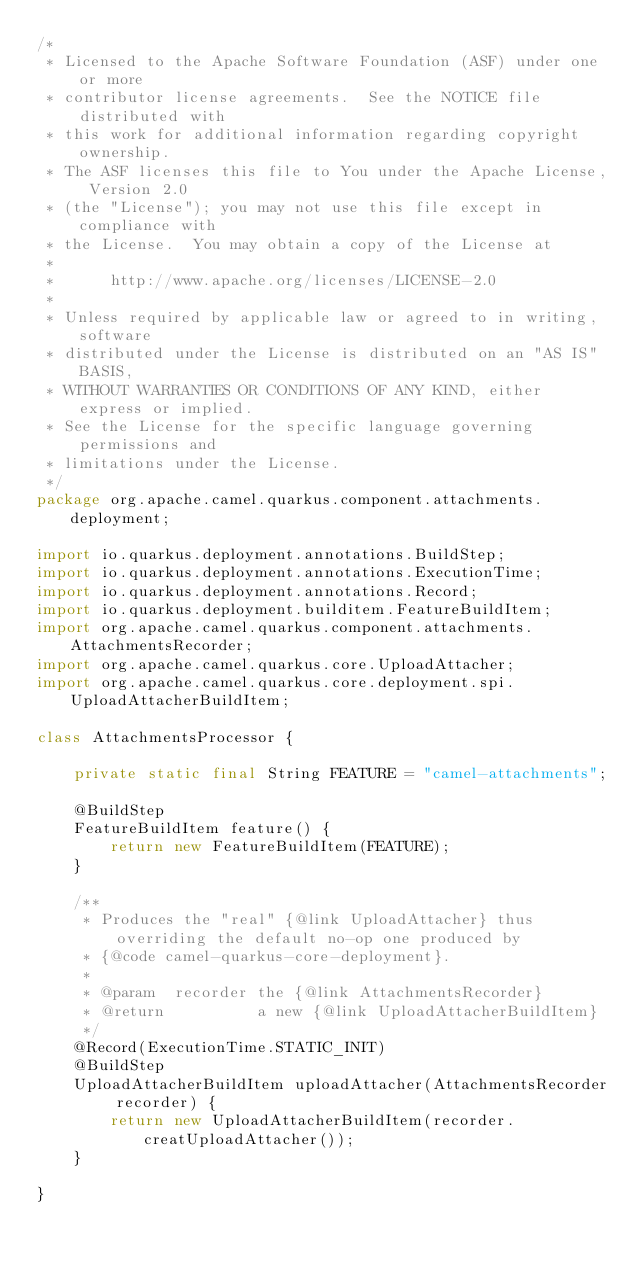Convert code to text. <code><loc_0><loc_0><loc_500><loc_500><_Java_>/*
 * Licensed to the Apache Software Foundation (ASF) under one or more
 * contributor license agreements.  See the NOTICE file distributed with
 * this work for additional information regarding copyright ownership.
 * The ASF licenses this file to You under the Apache License, Version 2.0
 * (the "License"); you may not use this file except in compliance with
 * the License.  You may obtain a copy of the License at
 *
 *      http://www.apache.org/licenses/LICENSE-2.0
 *
 * Unless required by applicable law or agreed to in writing, software
 * distributed under the License is distributed on an "AS IS" BASIS,
 * WITHOUT WARRANTIES OR CONDITIONS OF ANY KIND, either express or implied.
 * See the License for the specific language governing permissions and
 * limitations under the License.
 */
package org.apache.camel.quarkus.component.attachments.deployment;

import io.quarkus.deployment.annotations.BuildStep;
import io.quarkus.deployment.annotations.ExecutionTime;
import io.quarkus.deployment.annotations.Record;
import io.quarkus.deployment.builditem.FeatureBuildItem;
import org.apache.camel.quarkus.component.attachments.AttachmentsRecorder;
import org.apache.camel.quarkus.core.UploadAttacher;
import org.apache.camel.quarkus.core.deployment.spi.UploadAttacherBuildItem;

class AttachmentsProcessor {

    private static final String FEATURE = "camel-attachments";

    @BuildStep
    FeatureBuildItem feature() {
        return new FeatureBuildItem(FEATURE);
    }

    /**
     * Produces the "real" {@link UploadAttacher} thus overriding the default no-op one produced by
     * {@code camel-quarkus-core-deployment}.
     *
     * @param  recorder the {@link AttachmentsRecorder}
     * @return          a new {@link UploadAttacherBuildItem}
     */
    @Record(ExecutionTime.STATIC_INIT)
    @BuildStep
    UploadAttacherBuildItem uploadAttacher(AttachmentsRecorder recorder) {
        return new UploadAttacherBuildItem(recorder.creatUploadAttacher());
    }

}
</code> 